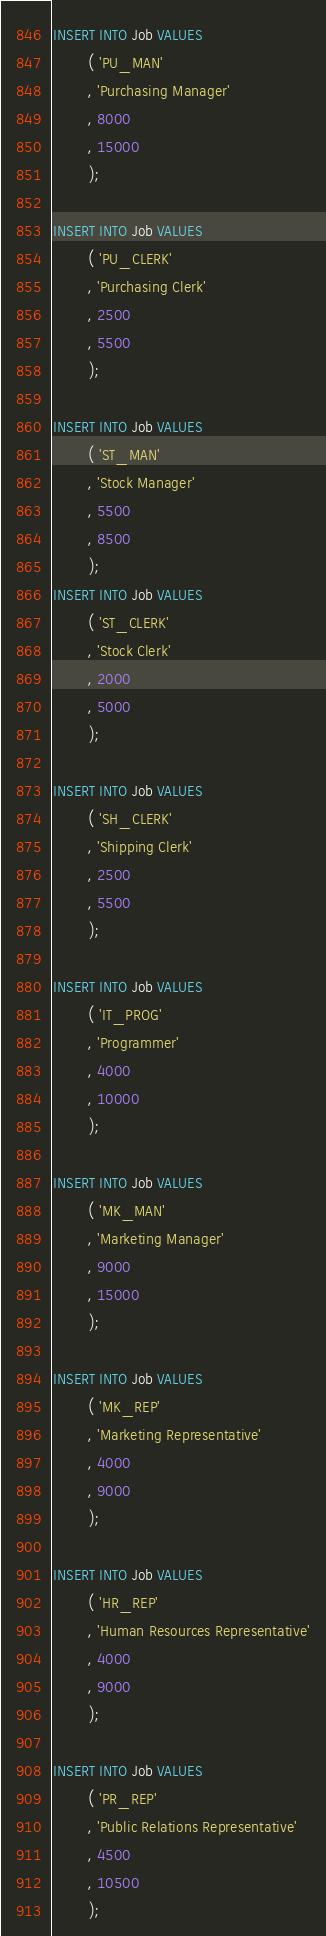Convert code to text. <code><loc_0><loc_0><loc_500><loc_500><_SQL_>
INSERT INTO Job VALUES
        ( 'PU_MAN'
        , 'Purchasing Manager'
        , 8000
        , 15000
        );

INSERT INTO Job VALUES
        ( 'PU_CLERK'
        , 'Purchasing Clerk'
        , 2500
        , 5500
        );

INSERT INTO Job VALUES
        ( 'ST_MAN'
        , 'Stock Manager'
        , 5500
        , 8500
        );
INSERT INTO Job VALUES
        ( 'ST_CLERK'
        , 'Stock Clerk'
        , 2000
        , 5000
        );

INSERT INTO Job VALUES
        ( 'SH_CLERK'
        , 'Shipping Clerk'
        , 2500
        , 5500
        );

INSERT INTO Job VALUES
        ( 'IT_PROG'
        , 'Programmer'
        , 4000
        , 10000
        );

INSERT INTO Job VALUES
        ( 'MK_MAN'
        , 'Marketing Manager'
        , 9000
        , 15000
        );

INSERT INTO Job VALUES
        ( 'MK_REP'
        , 'Marketing Representative'
        , 4000
        , 9000
        );

INSERT INTO Job VALUES
        ( 'HR_REP'
        , 'Human Resources Representative'
        , 4000
        , 9000
        );

INSERT INTO Job VALUES
        ( 'PR_REP'
        , 'Public Relations Representative'
        , 4500
        , 10500
        );
</code> 